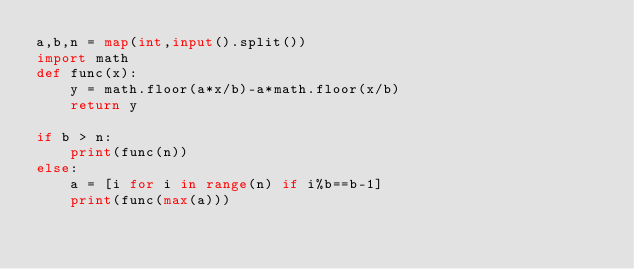<code> <loc_0><loc_0><loc_500><loc_500><_Python_>a,b,n = map(int,input().split())
import math
def func(x):
    y = math.floor(a*x/b)-a*math.floor(x/b)
    return y

if b > n:
    print(func(n))
else:
    a = [i for i in range(n) if i%b==b-1]
    print(func(max(a)))</code> 